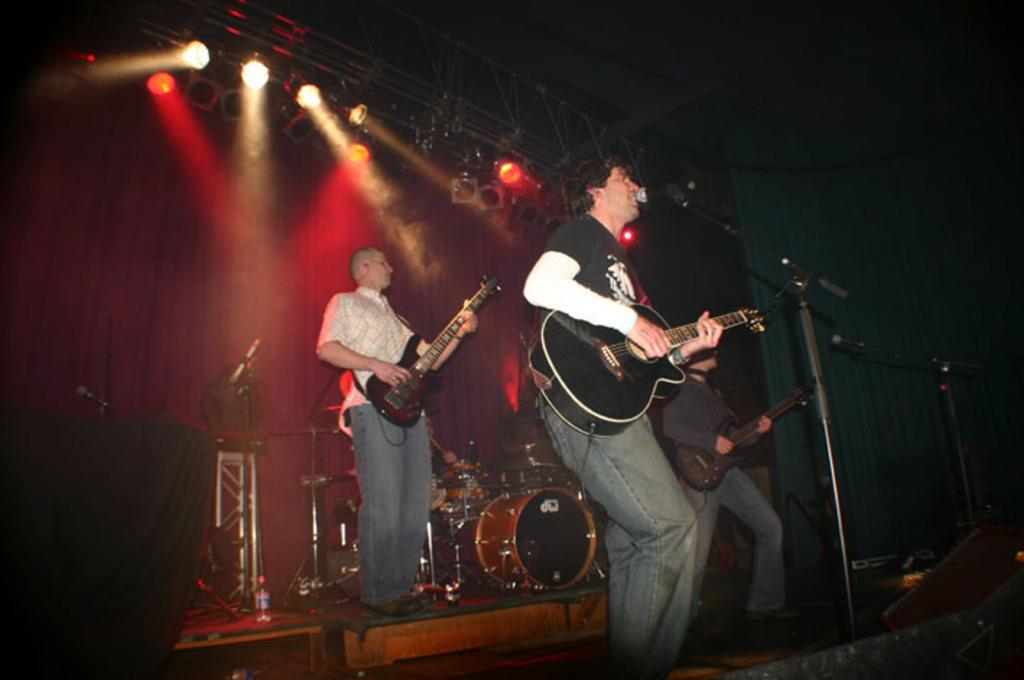How many people are in the image? There are three people standing in the image. What are the people doing in the image? The people are playing guitars, and there is a man singing using a microphone. What is the seated person doing in the image? The seated person is playing drums. Where are these activities taking place? All the mentioned activities are happening on a dais. What type of soup is being served on the dais in the image? There is no soup present in the image; it features people playing musical instruments and singing. 